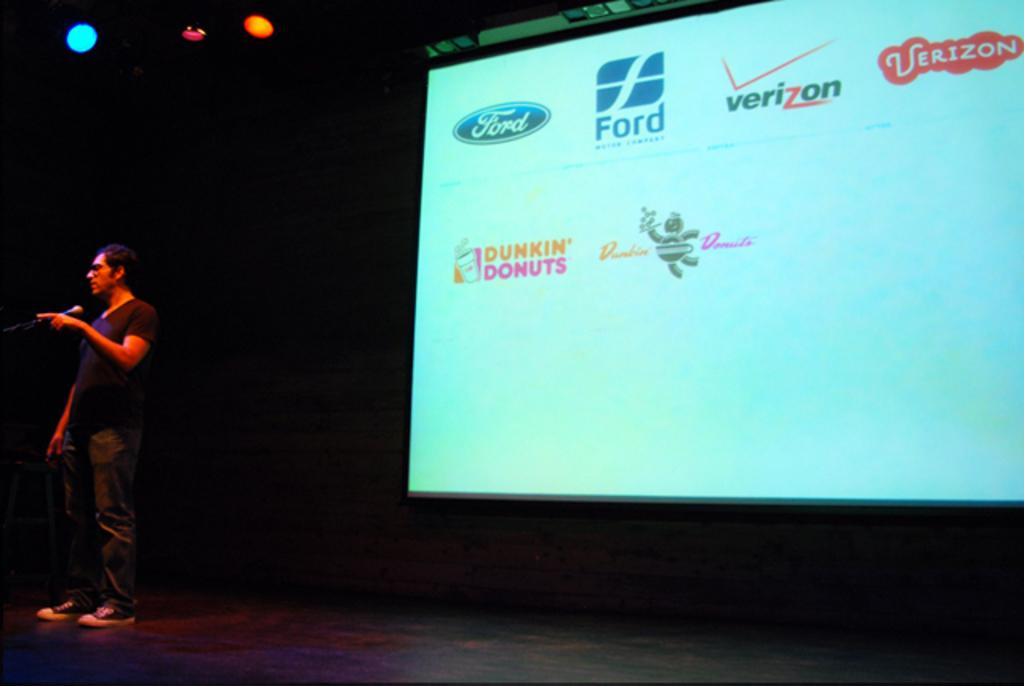<image>
Share a concise interpretation of the image provided. a screen that has a Dunkin Donuts logo on it 